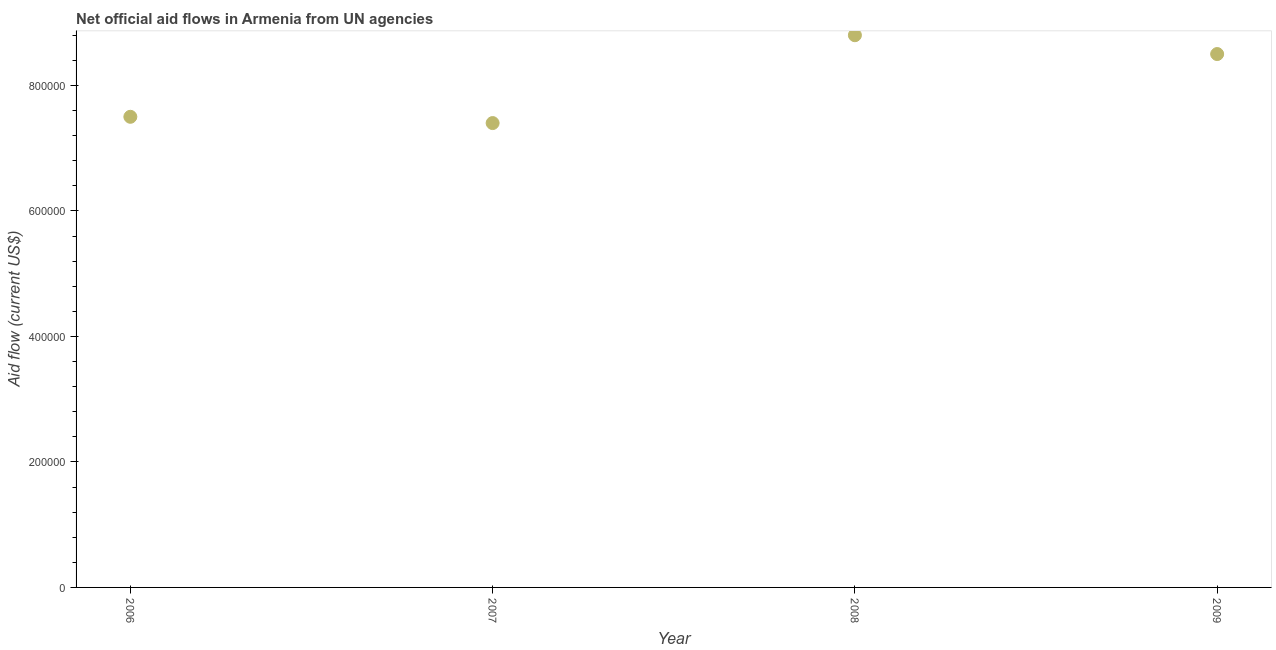What is the net official flows from un agencies in 2007?
Give a very brief answer. 7.40e+05. Across all years, what is the maximum net official flows from un agencies?
Give a very brief answer. 8.80e+05. Across all years, what is the minimum net official flows from un agencies?
Your answer should be very brief. 7.40e+05. In which year was the net official flows from un agencies maximum?
Offer a very short reply. 2008. What is the sum of the net official flows from un agencies?
Provide a succinct answer. 3.22e+06. What is the difference between the net official flows from un agencies in 2007 and 2008?
Make the answer very short. -1.40e+05. What is the average net official flows from un agencies per year?
Your answer should be compact. 8.05e+05. In how many years, is the net official flows from un agencies greater than 440000 US$?
Make the answer very short. 4. What is the ratio of the net official flows from un agencies in 2006 to that in 2007?
Provide a short and direct response. 1.01. Is the difference between the net official flows from un agencies in 2007 and 2009 greater than the difference between any two years?
Ensure brevity in your answer.  No. What is the difference between the highest and the lowest net official flows from un agencies?
Your answer should be compact. 1.40e+05. How many dotlines are there?
Your answer should be compact. 1. Are the values on the major ticks of Y-axis written in scientific E-notation?
Your answer should be very brief. No. Does the graph contain any zero values?
Your answer should be very brief. No. What is the title of the graph?
Make the answer very short. Net official aid flows in Armenia from UN agencies. What is the label or title of the X-axis?
Offer a terse response. Year. What is the Aid flow (current US$) in 2006?
Offer a very short reply. 7.50e+05. What is the Aid flow (current US$) in 2007?
Your response must be concise. 7.40e+05. What is the Aid flow (current US$) in 2008?
Ensure brevity in your answer.  8.80e+05. What is the Aid flow (current US$) in 2009?
Provide a succinct answer. 8.50e+05. What is the difference between the Aid flow (current US$) in 2006 and 2007?
Offer a very short reply. 10000. What is the difference between the Aid flow (current US$) in 2006 and 2008?
Offer a terse response. -1.30e+05. What is the difference between the Aid flow (current US$) in 2007 and 2009?
Your response must be concise. -1.10e+05. What is the difference between the Aid flow (current US$) in 2008 and 2009?
Make the answer very short. 3.00e+04. What is the ratio of the Aid flow (current US$) in 2006 to that in 2007?
Offer a terse response. 1.01. What is the ratio of the Aid flow (current US$) in 2006 to that in 2008?
Provide a short and direct response. 0.85. What is the ratio of the Aid flow (current US$) in 2006 to that in 2009?
Provide a succinct answer. 0.88. What is the ratio of the Aid flow (current US$) in 2007 to that in 2008?
Your answer should be very brief. 0.84. What is the ratio of the Aid flow (current US$) in 2007 to that in 2009?
Provide a short and direct response. 0.87. What is the ratio of the Aid flow (current US$) in 2008 to that in 2009?
Offer a terse response. 1.03. 